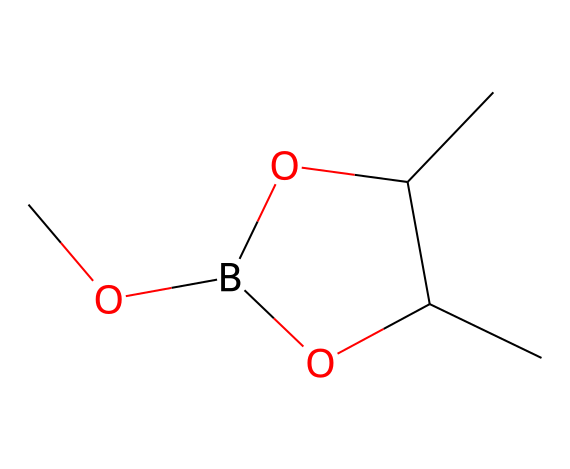What is the main functional group in this borane compound? The compound contains a boron atom bonded to several hydroxyl groups (–OH) and an ether group (–O–), which are considered functional groups. The presence of hydroxyl groups indicates the functionality related to alcohols.
Answer: hydroxyl group How many carbon atoms are in the structure? Counting the carbon atoms in the SMILES representation shows that there are four carbon atoms in total. Each carbon atom is represented by the letter 'C'.
Answer: four What type of bonding is present between boron and oxygen in this compound? The bonding between boron and oxygen in borane complexes typically exhibits coordination covalent bonding. This is due to the electron deficiency of boron, which can accept electron pairs from the oxygen atoms.
Answer: coordination covalent bonding Is this compound likely to be polar or nonpolar? Since the compound has multiple hydroxyl (–OH) groups, which are polar, the overall structure would exhibit a polar character due to the electronegativity difference between boron, oxygen, and carbon.
Answer: polar What is the degree of saturation of this borane complex? The degree of saturation can be assessed by analyzing the number of hydrogen atoms related to the amount of carbon present. As the structure contains no rings or double bonds, it remains fully saturated.
Answer: fully saturated Which atom in the complex is considered the central atom? In this borane structure, the central atom is boron, as it forms the core of the molecular structure with surrounding groups.
Answer: boron 